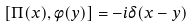<formula> <loc_0><loc_0><loc_500><loc_500>[ \Pi ( x ) , \phi ( y ) ] = - i \delta ( x - y )</formula> 